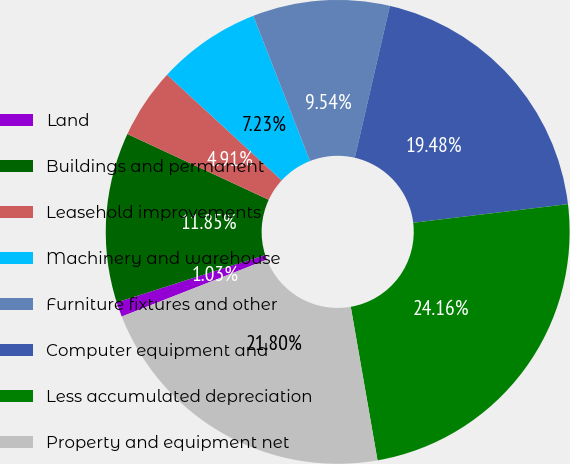<chart> <loc_0><loc_0><loc_500><loc_500><pie_chart><fcel>Land<fcel>Buildings and permanent<fcel>Leasehold improvements<fcel>Machinery and warehouse<fcel>Furniture fixtures and other<fcel>Computer equipment and<fcel>Less accumulated depreciation<fcel>Property and equipment net<nl><fcel>1.03%<fcel>11.85%<fcel>4.91%<fcel>7.23%<fcel>9.54%<fcel>19.48%<fcel>24.16%<fcel>21.8%<nl></chart> 